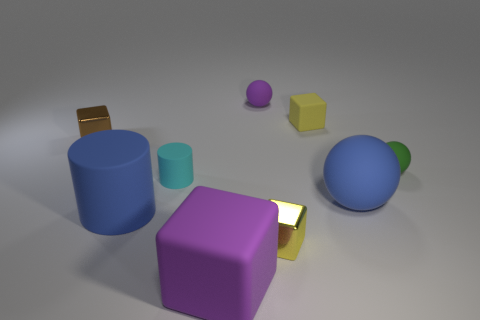How big is the brown block?
Give a very brief answer. Small. There is a small thing that is the same color as the large block; what is its shape?
Ensure brevity in your answer.  Sphere. What number of cylinders are tiny cyan rubber things or tiny yellow objects?
Provide a short and direct response. 1. Are there an equal number of matte balls behind the green matte thing and tiny matte balls right of the small purple thing?
Provide a succinct answer. Yes. There is a blue rubber thing that is the same shape as the green matte object; what is its size?
Your answer should be compact. Large. There is a rubber thing that is behind the big blue rubber ball and on the left side of the big cube; what is its size?
Provide a short and direct response. Small. Are there any tiny spheres right of the yellow shiny object?
Offer a terse response. Yes. What number of objects are either small cyan rubber objects in front of the small purple ball or small cyan objects?
Your answer should be compact. 1. There is a shiny block behind the big blue cylinder; how many metallic things are right of it?
Give a very brief answer. 1. Is the number of large blue cylinders that are in front of the tiny cyan matte cylinder less than the number of small objects that are behind the brown cube?
Ensure brevity in your answer.  Yes. 